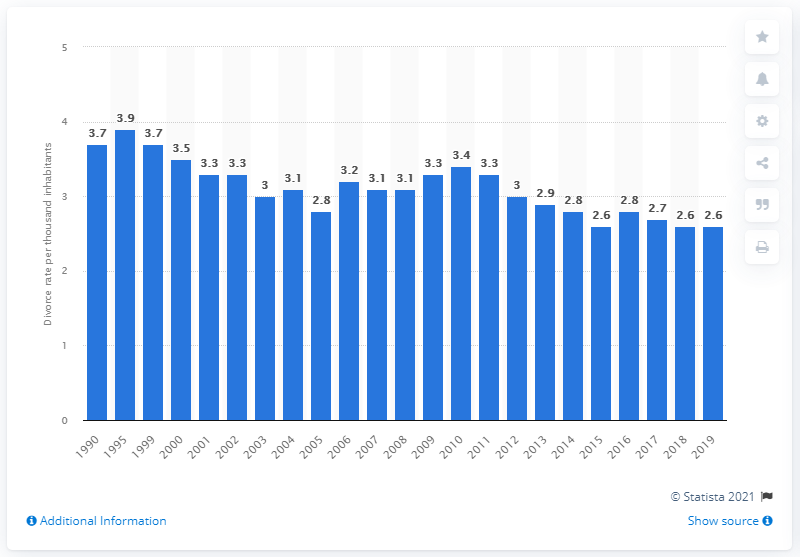Highlight a few significant elements in this photo. According to data from 2019, the divorce rate in South Dakota was 2.6 per thousand inhabitants. In 1990, the divorce rate in South Dakota was 3.7 per 1,000 people. 